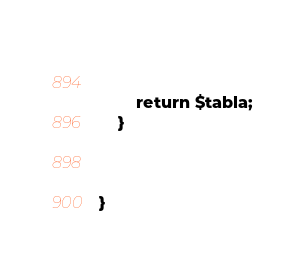Convert code to text. <code><loc_0><loc_0><loc_500><loc_500><_PHP_>

    
     
        return $tabla;
    }


  
}
</code> 